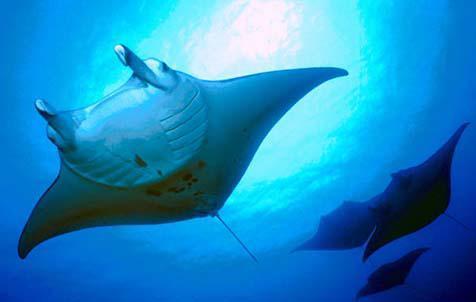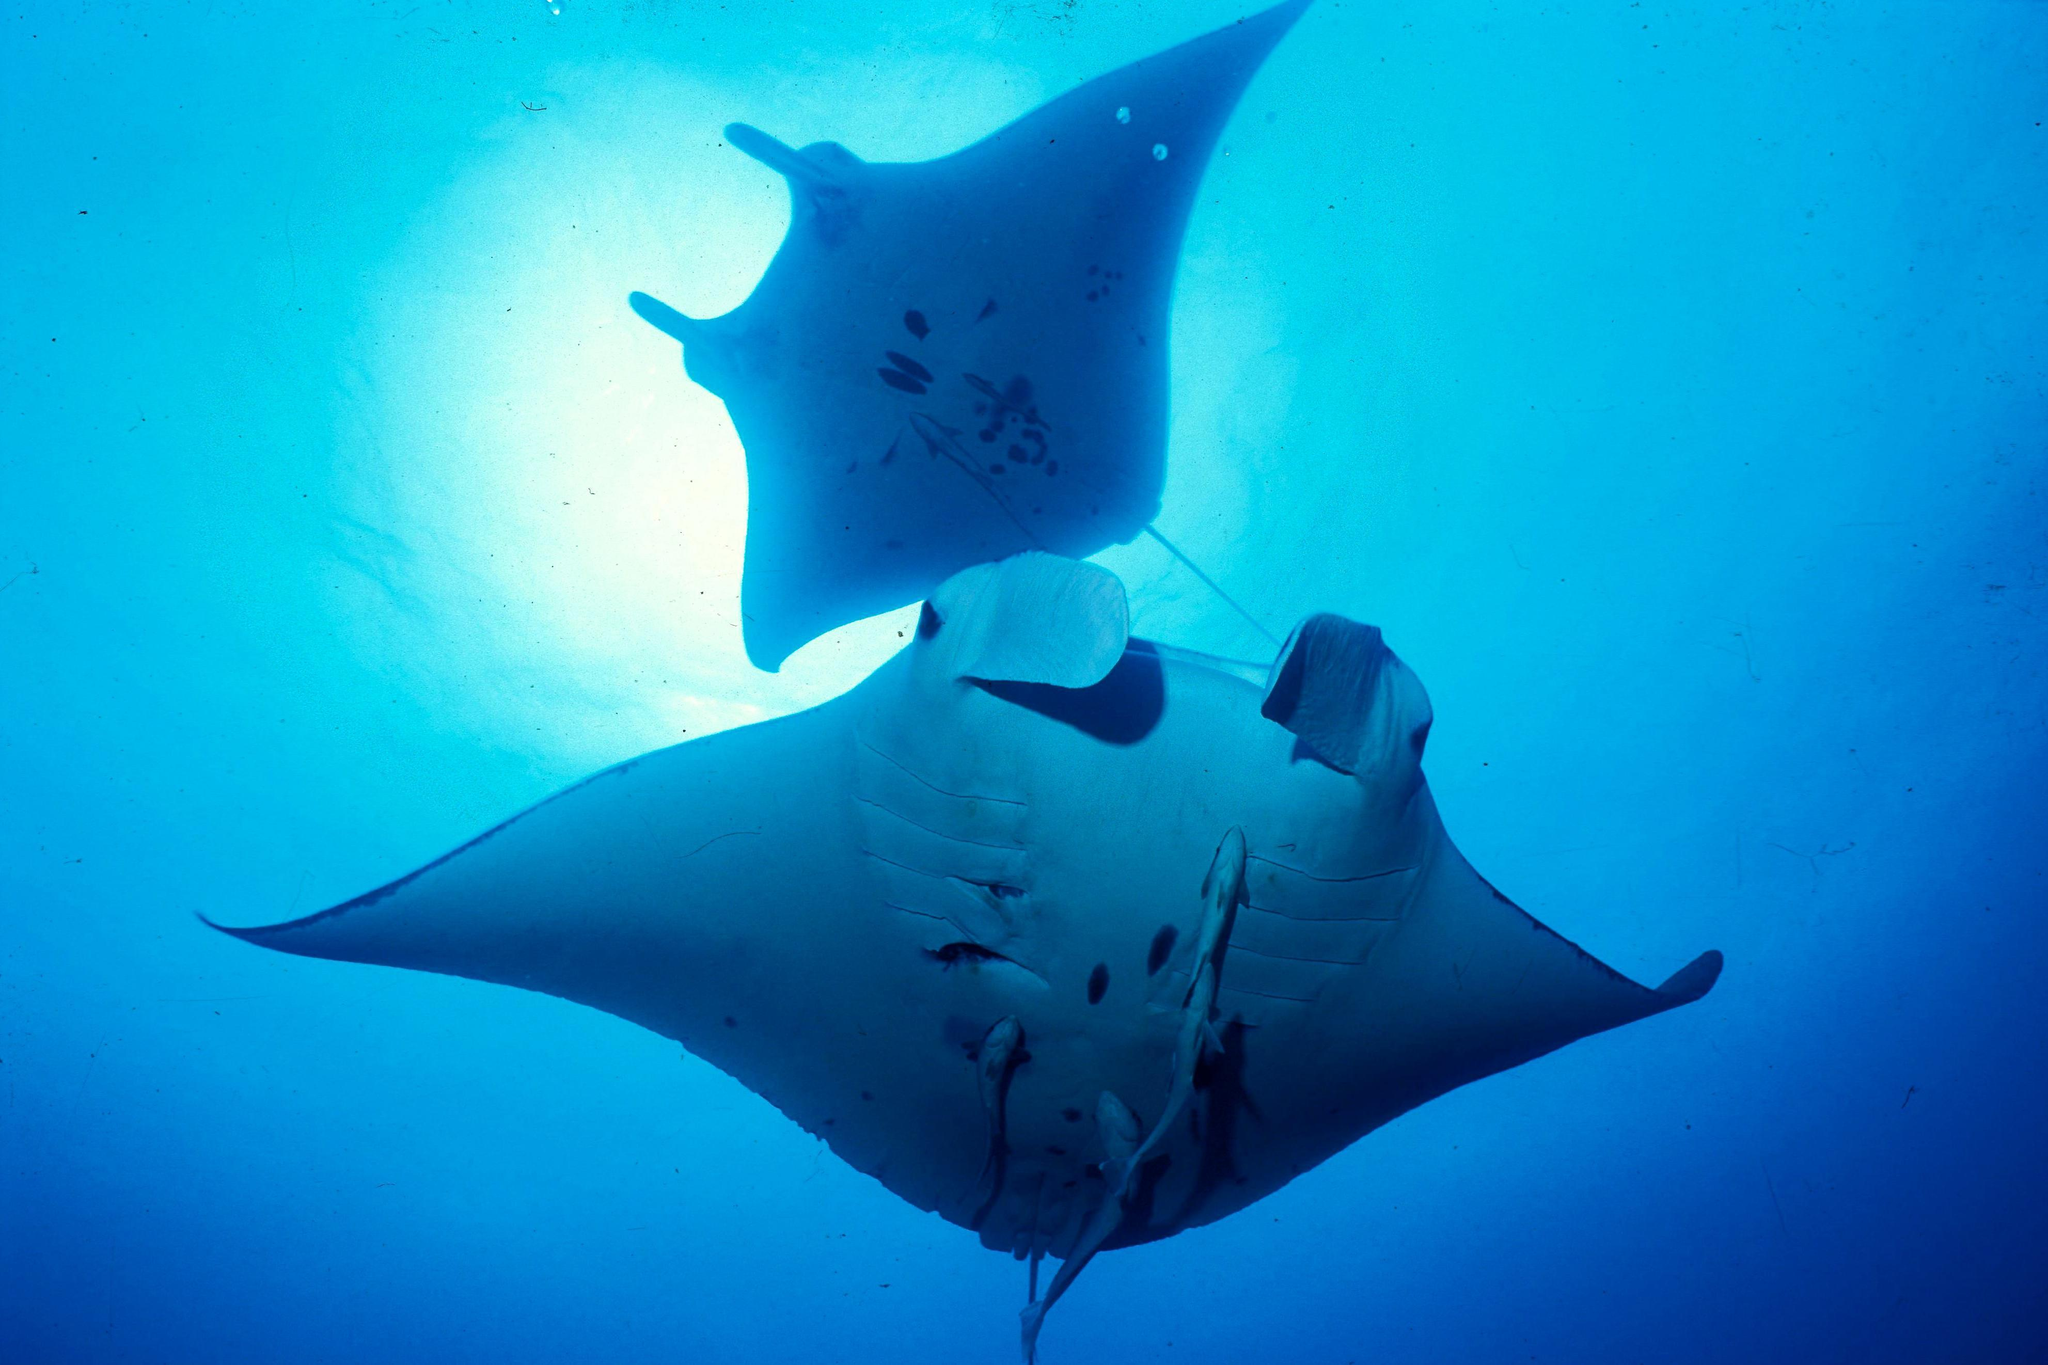The first image is the image on the left, the second image is the image on the right. Assess this claim about the two images: "An image contains exactly two stingray swimming in blue water with light shining in the scene.". Correct or not? Answer yes or no. Yes. The first image is the image on the left, the second image is the image on the right. Examine the images to the left and right. Is the description "There are two manta rays in total." accurate? Answer yes or no. No. 